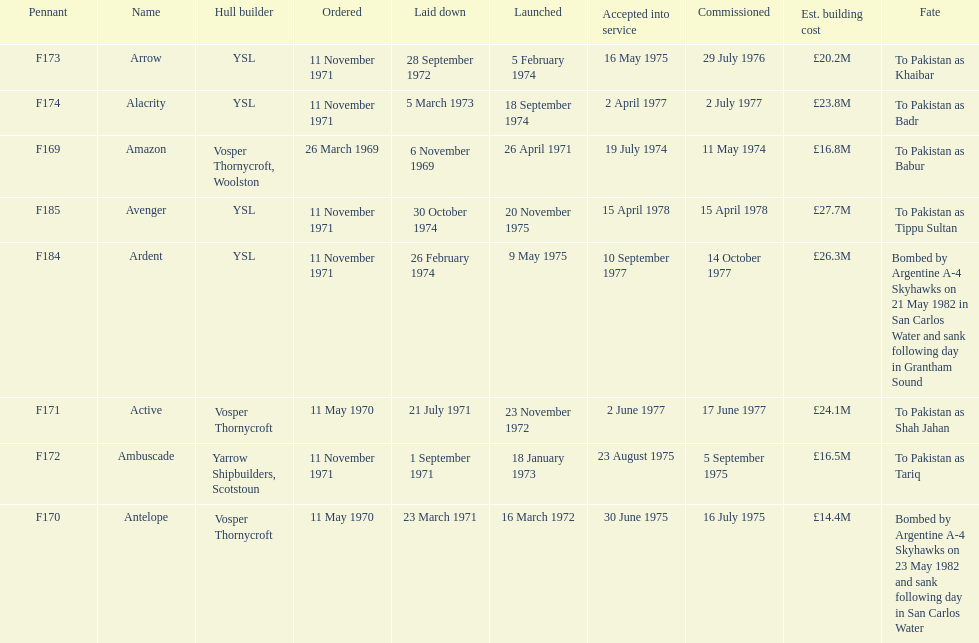Tell me the number of ships that went to pakistan. 6. 